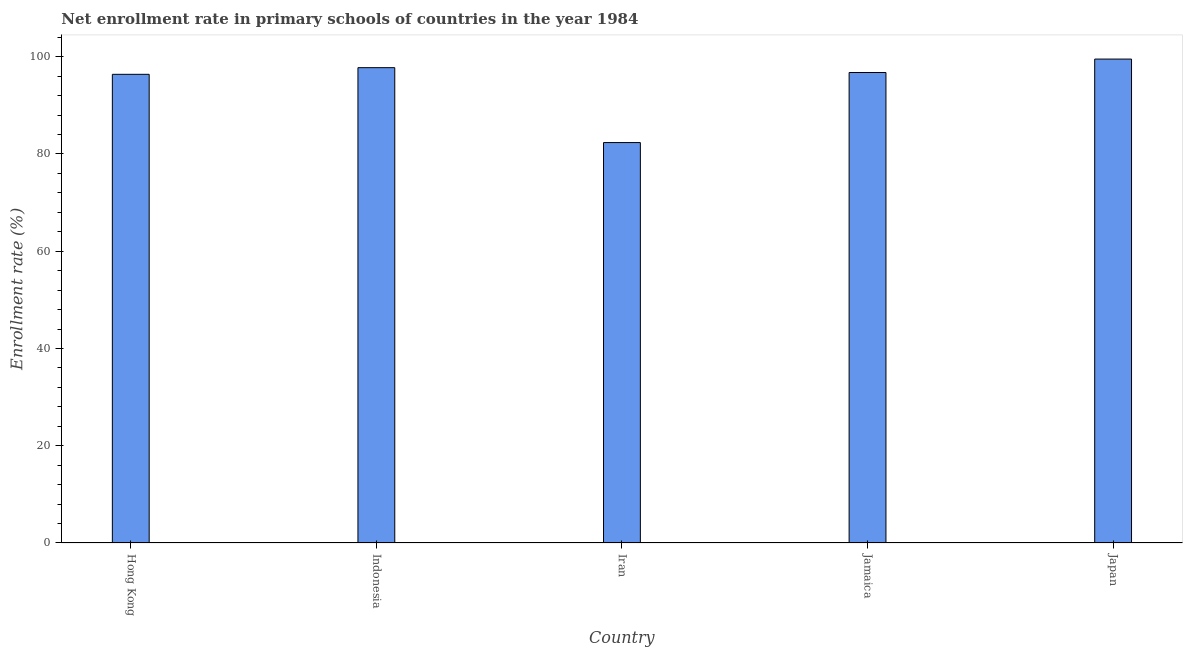Does the graph contain grids?
Give a very brief answer. No. What is the title of the graph?
Keep it short and to the point. Net enrollment rate in primary schools of countries in the year 1984. What is the label or title of the X-axis?
Your answer should be compact. Country. What is the label or title of the Y-axis?
Your response must be concise. Enrollment rate (%). What is the net enrollment rate in primary schools in Indonesia?
Your answer should be compact. 97.75. Across all countries, what is the maximum net enrollment rate in primary schools?
Your response must be concise. 99.52. Across all countries, what is the minimum net enrollment rate in primary schools?
Give a very brief answer. 82.35. In which country was the net enrollment rate in primary schools maximum?
Your answer should be compact. Japan. In which country was the net enrollment rate in primary schools minimum?
Provide a succinct answer. Iran. What is the sum of the net enrollment rate in primary schools?
Make the answer very short. 472.77. What is the average net enrollment rate in primary schools per country?
Provide a short and direct response. 94.55. What is the median net enrollment rate in primary schools?
Your answer should be very brief. 96.76. What is the ratio of the net enrollment rate in primary schools in Iran to that in Jamaica?
Your answer should be compact. 0.85. What is the difference between the highest and the second highest net enrollment rate in primary schools?
Keep it short and to the point. 1.77. What is the difference between the highest and the lowest net enrollment rate in primary schools?
Your answer should be very brief. 17.17. How many bars are there?
Offer a very short reply. 5. Are all the bars in the graph horizontal?
Keep it short and to the point. No. What is the difference between two consecutive major ticks on the Y-axis?
Make the answer very short. 20. What is the Enrollment rate (%) of Hong Kong?
Offer a terse response. 96.39. What is the Enrollment rate (%) in Indonesia?
Keep it short and to the point. 97.75. What is the Enrollment rate (%) of Iran?
Your response must be concise. 82.35. What is the Enrollment rate (%) of Jamaica?
Offer a terse response. 96.76. What is the Enrollment rate (%) in Japan?
Your answer should be compact. 99.52. What is the difference between the Enrollment rate (%) in Hong Kong and Indonesia?
Provide a succinct answer. -1.37. What is the difference between the Enrollment rate (%) in Hong Kong and Iran?
Provide a short and direct response. 14.04. What is the difference between the Enrollment rate (%) in Hong Kong and Jamaica?
Your answer should be compact. -0.37. What is the difference between the Enrollment rate (%) in Hong Kong and Japan?
Your answer should be very brief. -3.14. What is the difference between the Enrollment rate (%) in Indonesia and Iran?
Your response must be concise. 15.4. What is the difference between the Enrollment rate (%) in Indonesia and Jamaica?
Provide a succinct answer. 0.99. What is the difference between the Enrollment rate (%) in Indonesia and Japan?
Make the answer very short. -1.77. What is the difference between the Enrollment rate (%) in Iran and Jamaica?
Your answer should be very brief. -14.41. What is the difference between the Enrollment rate (%) in Iran and Japan?
Ensure brevity in your answer.  -17.17. What is the difference between the Enrollment rate (%) in Jamaica and Japan?
Provide a short and direct response. -2.76. What is the ratio of the Enrollment rate (%) in Hong Kong to that in Iran?
Provide a succinct answer. 1.17. What is the ratio of the Enrollment rate (%) in Hong Kong to that in Jamaica?
Your response must be concise. 1. What is the ratio of the Enrollment rate (%) in Hong Kong to that in Japan?
Ensure brevity in your answer.  0.97. What is the ratio of the Enrollment rate (%) in Indonesia to that in Iran?
Provide a succinct answer. 1.19. What is the ratio of the Enrollment rate (%) in Indonesia to that in Jamaica?
Your answer should be very brief. 1.01. What is the ratio of the Enrollment rate (%) in Iran to that in Jamaica?
Provide a succinct answer. 0.85. What is the ratio of the Enrollment rate (%) in Iran to that in Japan?
Offer a very short reply. 0.83. What is the ratio of the Enrollment rate (%) in Jamaica to that in Japan?
Make the answer very short. 0.97. 